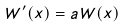<formula> <loc_0><loc_0><loc_500><loc_500>W ^ { \prime } ( x ) = a W ( x )</formula> 